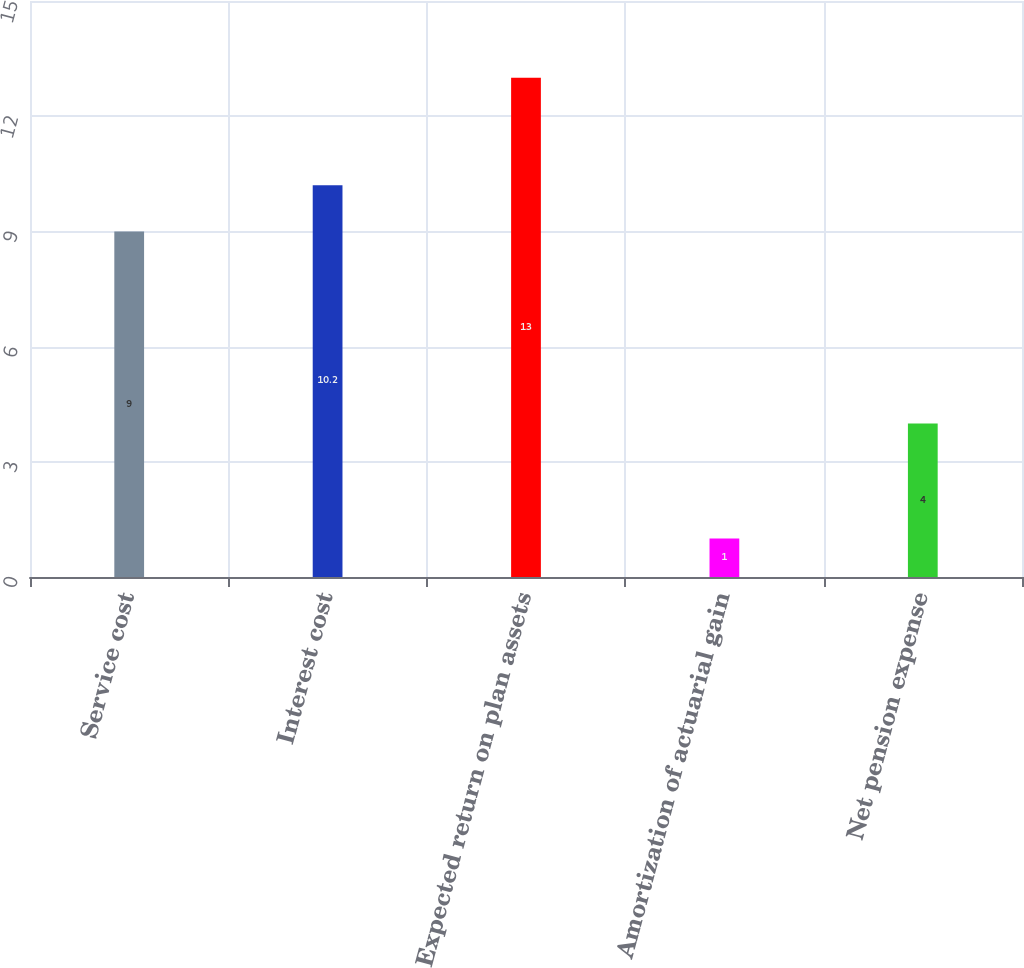Convert chart to OTSL. <chart><loc_0><loc_0><loc_500><loc_500><bar_chart><fcel>Service cost<fcel>Interest cost<fcel>Expected return on plan assets<fcel>Amortization of actuarial gain<fcel>Net pension expense<nl><fcel>9<fcel>10.2<fcel>13<fcel>1<fcel>4<nl></chart> 